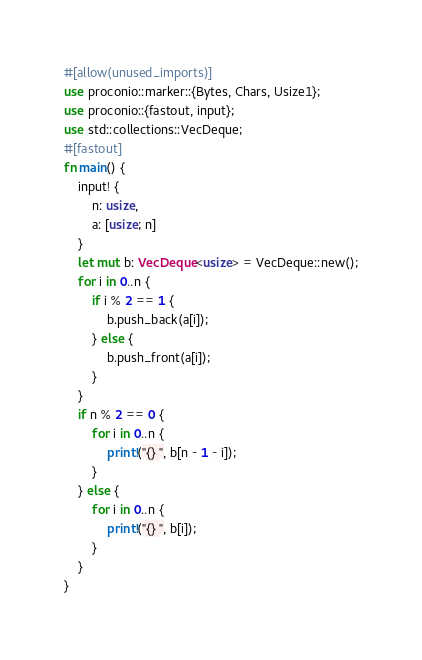<code> <loc_0><loc_0><loc_500><loc_500><_Rust_>#[allow(unused_imports)]
use proconio::marker::{Bytes, Chars, Usize1};
use proconio::{fastout, input};
use std::collections::VecDeque;
#[fastout]
fn main() {
    input! {
        n: usize,
        a: [usize; n]
    }
    let mut b: VecDeque<usize> = VecDeque::new();
    for i in 0..n {
        if i % 2 == 1 {
            b.push_back(a[i]);
        } else {
            b.push_front(a[i]);
        }
    }
    if n % 2 == 0 {
        for i in 0..n {
            print!("{} ", b[n - 1 - i]);
        }
    } else {
        for i in 0..n {
            print!("{} ", b[i]);
        }
    }
}
</code> 